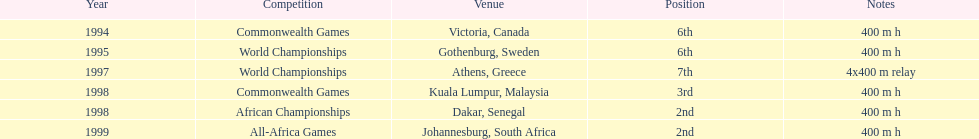What is the total number of competitions on this chart? 6. Give me the full table as a dictionary. {'header': ['Year', 'Competition', 'Venue', 'Position', 'Notes'], 'rows': [['1994', 'Commonwealth Games', 'Victoria, Canada', '6th', '400 m h'], ['1995', 'World Championships', 'Gothenburg, Sweden', '6th', '400 m h'], ['1997', 'World Championships', 'Athens, Greece', '7th', '4x400 m relay'], ['1998', 'Commonwealth Games', 'Kuala Lumpur, Malaysia', '3rd', '400 m h'], ['1998', 'African Championships', 'Dakar, Senegal', '2nd', '400 m h'], ['1999', 'All-Africa Games', 'Johannesburg, South Africa', '2nd', '400 m h']]} 